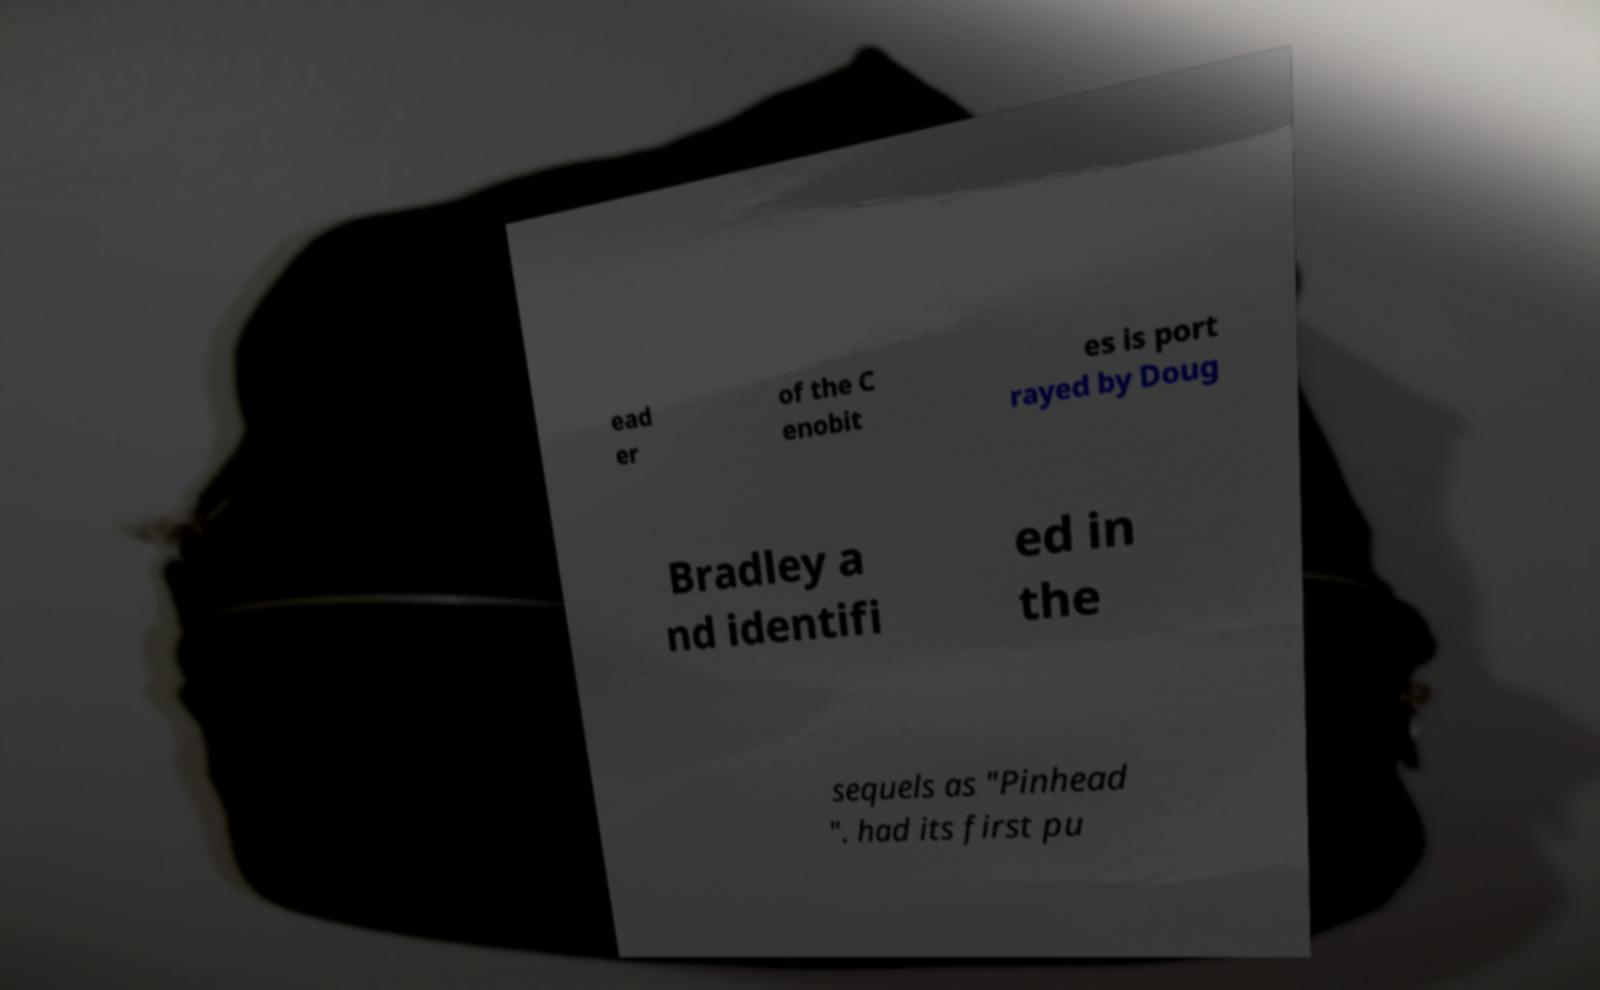Please identify and transcribe the text found in this image. ead er of the C enobit es is port rayed by Doug Bradley a nd identifi ed in the sequels as "Pinhead ". had its first pu 